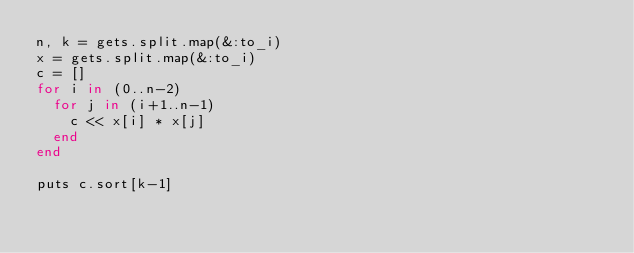Convert code to text. <code><loc_0><loc_0><loc_500><loc_500><_Ruby_>n, k = gets.split.map(&:to_i)
x = gets.split.map(&:to_i)
c = []
for i in (0..n-2)
  for j in (i+1..n-1)
    c << x[i] * x[j]
  end
end

puts c.sort[k-1]
</code> 